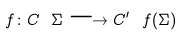Convert formula to latex. <formula><loc_0><loc_0><loc_500><loc_500>f \colon C \ \Sigma \longrightarrow C ^ { \prime } \ f ( \Sigma )</formula> 